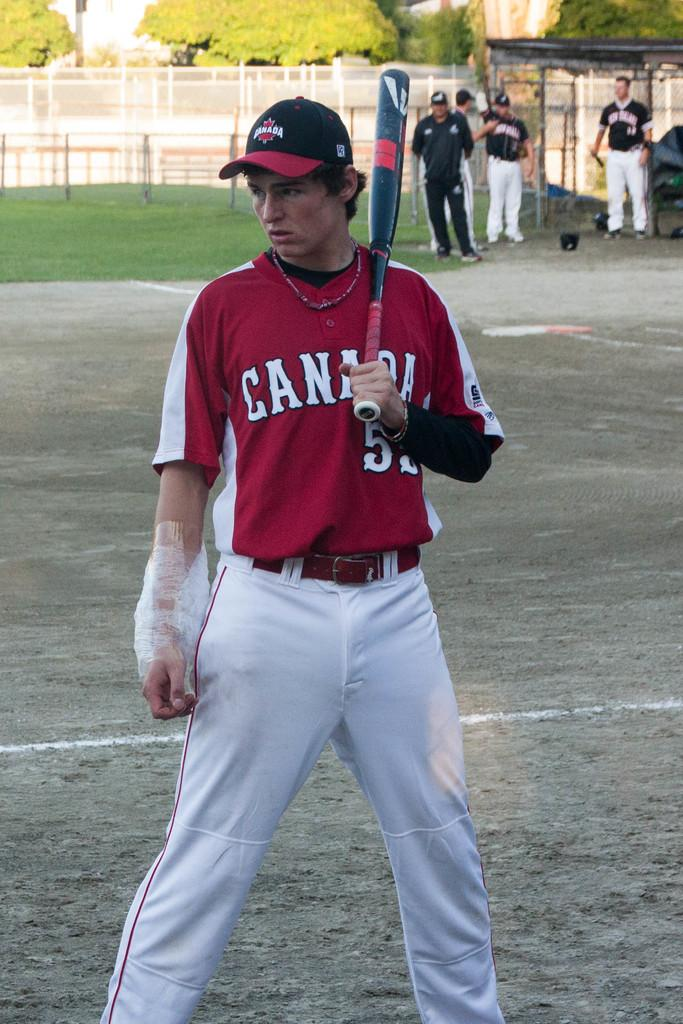<image>
Share a concise interpretation of the image provided. A Canada player holds a bat over his shoulder. 